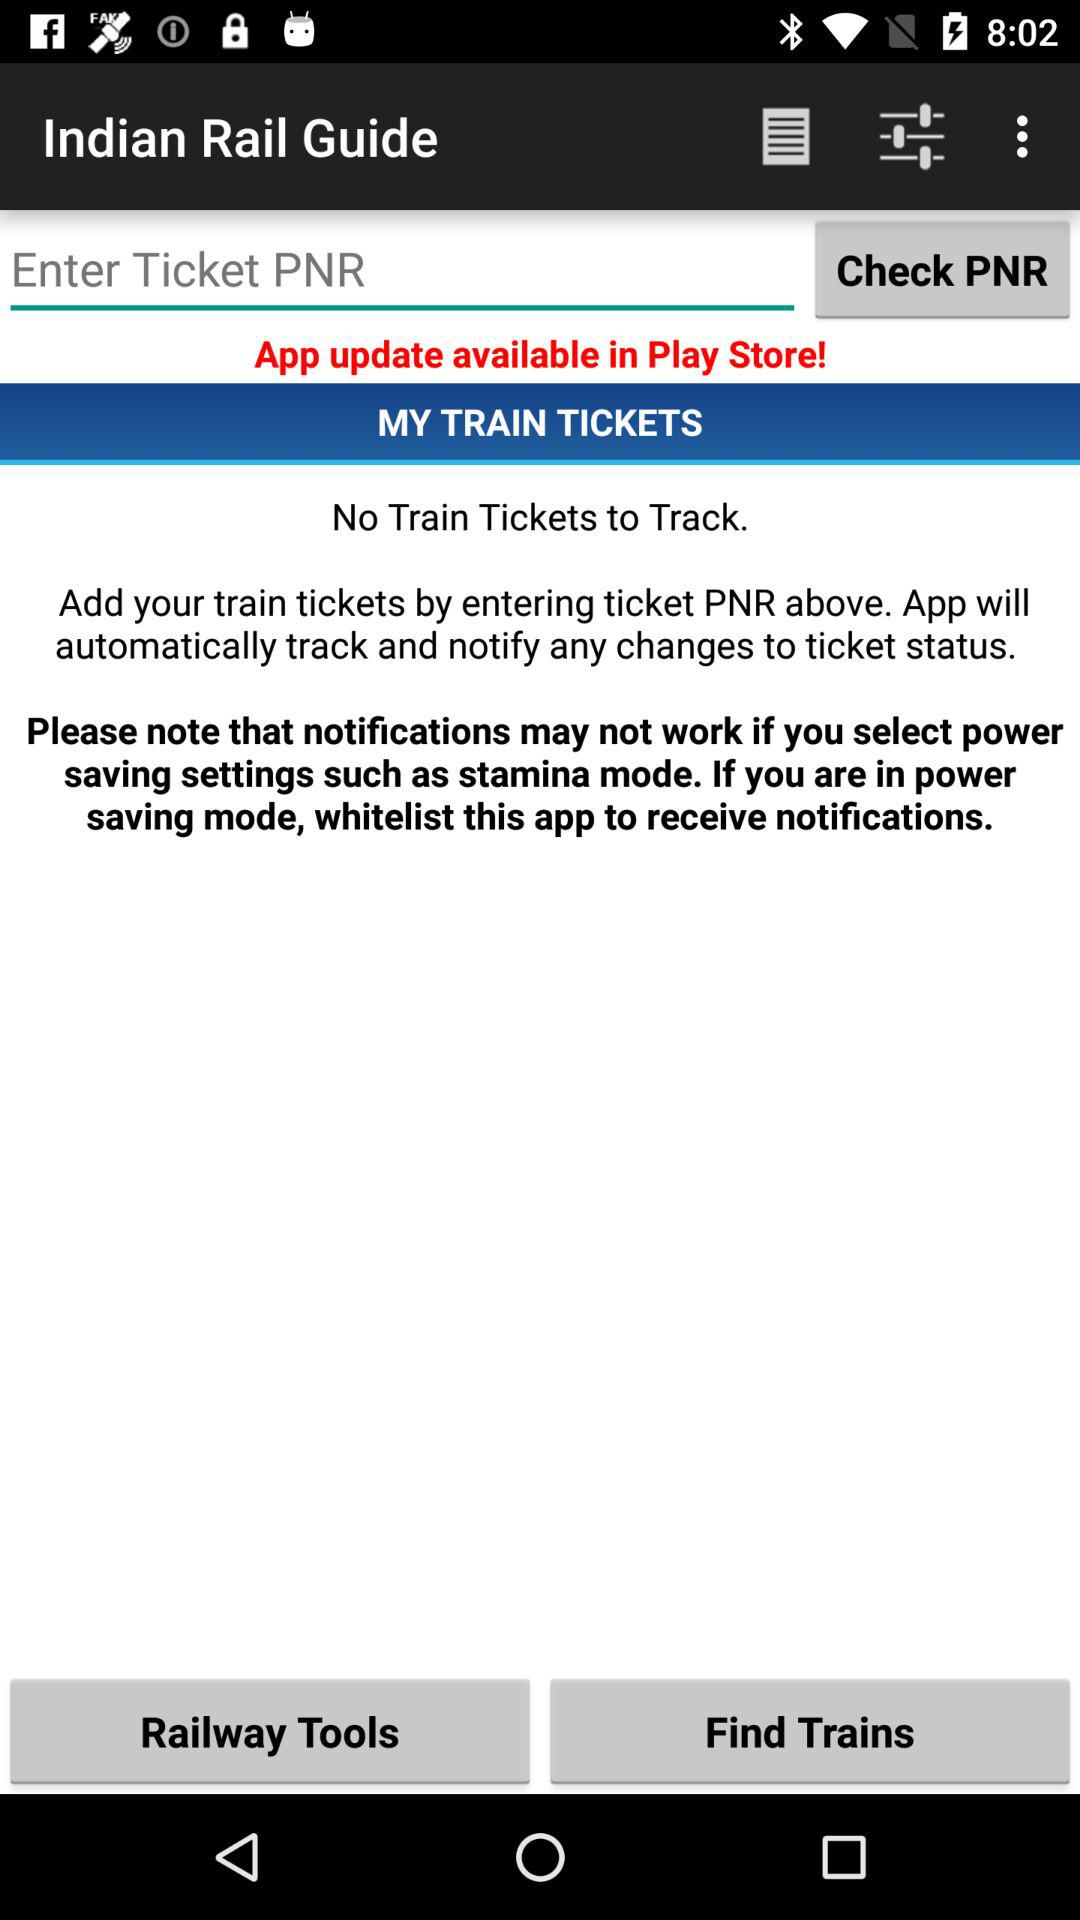What is the name of the application? The name of the application is "Indian Rail Guide". 